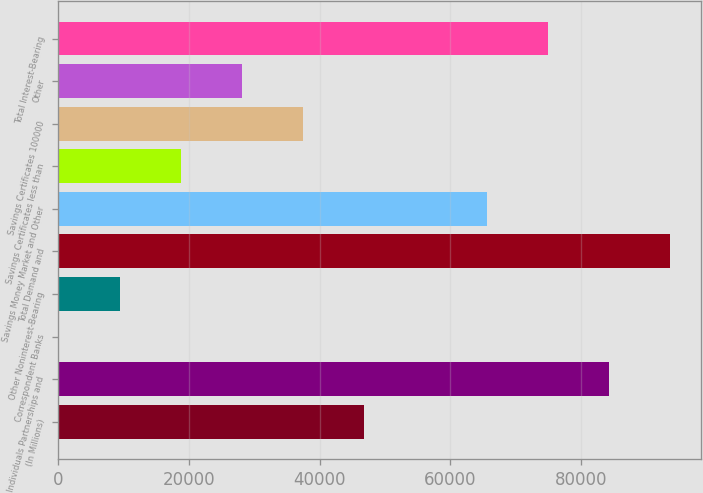<chart> <loc_0><loc_0><loc_500><loc_500><bar_chart><fcel>(In Millions)<fcel>Individuals Partnerships and<fcel>Correspondent Banks<fcel>Other Noninterest-Bearing<fcel>Total Demand and<fcel>Savings Money Market and Other<fcel>Savings Certificates less than<fcel>Savings Certificates 100000<fcel>Other<fcel>Total Interest-Bearing<nl><fcel>46835.9<fcel>84258.3<fcel>58<fcel>9413.59<fcel>93613.9<fcel>65547.1<fcel>18769.2<fcel>37480.4<fcel>28124.8<fcel>74902.7<nl></chart> 